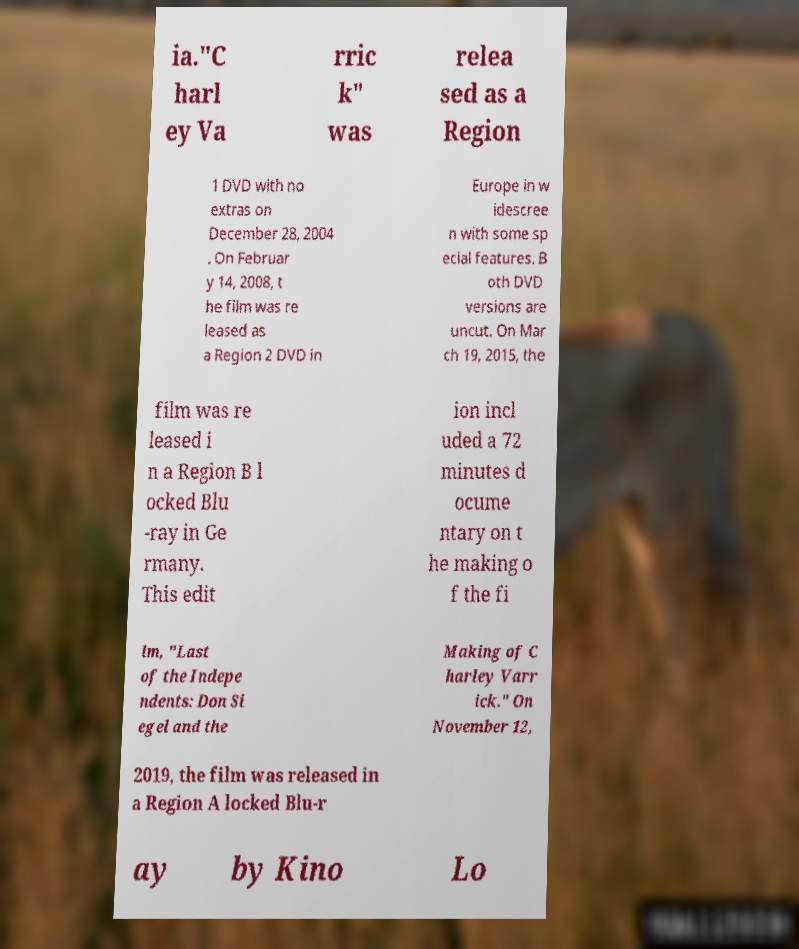I need the written content from this picture converted into text. Can you do that? ia."C harl ey Va rric k" was relea sed as a Region 1 DVD with no extras on December 28, 2004 . On Februar y 14, 2008, t he film was re leased as a Region 2 DVD in Europe in w idescree n with some sp ecial features. B oth DVD versions are uncut. On Mar ch 19, 2015, the film was re leased i n a Region B l ocked Blu -ray in Ge rmany. This edit ion incl uded a 72 minutes d ocume ntary on t he making o f the fi lm, "Last of the Indepe ndents: Don Si egel and the Making of C harley Varr ick." On November 12, 2019, the film was released in a Region A locked Blu-r ay by Kino Lo 